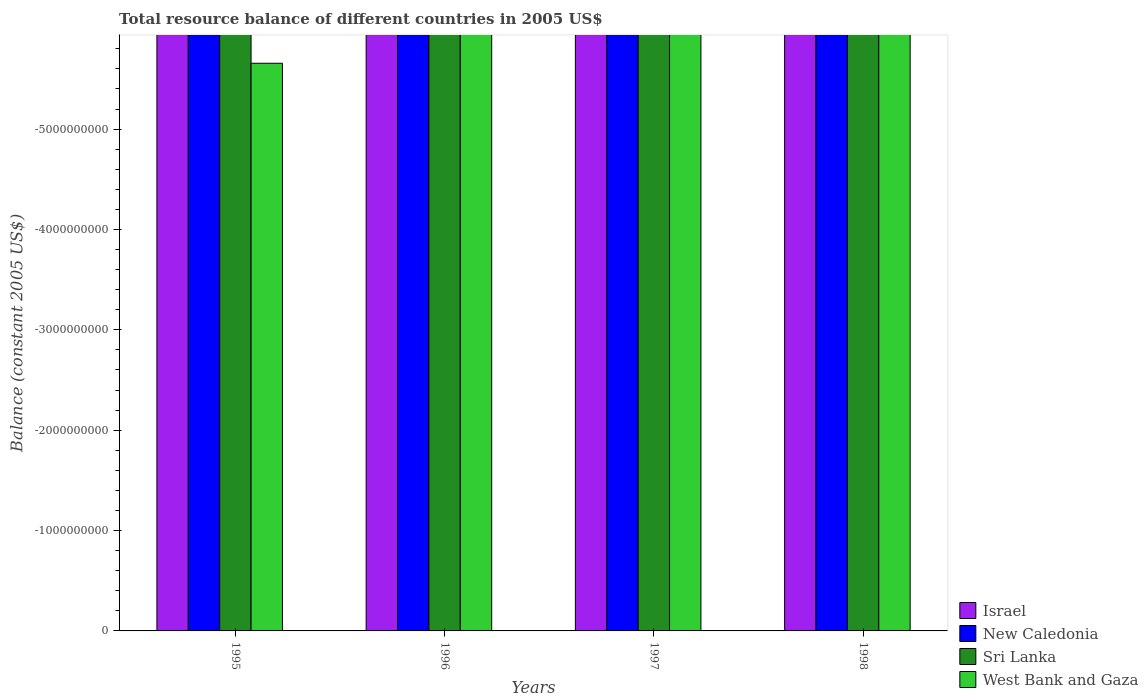Are the number of bars per tick equal to the number of legend labels?
Your response must be concise. No. Are the number of bars on each tick of the X-axis equal?
Give a very brief answer. Yes. How many bars are there on the 3rd tick from the left?
Provide a succinct answer. 0. In how many cases, is the number of bars for a given year not equal to the number of legend labels?
Keep it short and to the point. 4. In how many years, is the total resource balance in Sri Lanka greater than -5400000000 US$?
Keep it short and to the point. 0. Is it the case that in every year, the sum of the total resource balance in Israel and total resource balance in West Bank and Gaza is greater than the total resource balance in New Caledonia?
Keep it short and to the point. No. How many bars are there?
Ensure brevity in your answer.  0. How many years are there in the graph?
Provide a short and direct response. 4. What is the difference between two consecutive major ticks on the Y-axis?
Your response must be concise. 1.00e+09. Does the graph contain any zero values?
Offer a terse response. Yes. Does the graph contain grids?
Keep it short and to the point. No. What is the title of the graph?
Make the answer very short. Total resource balance of different countries in 2005 US$. What is the label or title of the Y-axis?
Offer a very short reply. Balance (constant 2005 US$). What is the Balance (constant 2005 US$) of New Caledonia in 1995?
Your answer should be very brief. 0. What is the Balance (constant 2005 US$) in West Bank and Gaza in 1995?
Your answer should be compact. 0. What is the Balance (constant 2005 US$) of Sri Lanka in 1996?
Your answer should be very brief. 0. What is the Balance (constant 2005 US$) in West Bank and Gaza in 1996?
Offer a very short reply. 0. What is the Balance (constant 2005 US$) of Israel in 1997?
Keep it short and to the point. 0. What is the Balance (constant 2005 US$) of Sri Lanka in 1997?
Make the answer very short. 0. What is the Balance (constant 2005 US$) in West Bank and Gaza in 1997?
Your answer should be very brief. 0. What is the Balance (constant 2005 US$) in Israel in 1998?
Your answer should be compact. 0. What is the Balance (constant 2005 US$) of West Bank and Gaza in 1998?
Offer a very short reply. 0. What is the total Balance (constant 2005 US$) in Israel in the graph?
Keep it short and to the point. 0. What is the total Balance (constant 2005 US$) of New Caledonia in the graph?
Provide a short and direct response. 0. What is the total Balance (constant 2005 US$) of Sri Lanka in the graph?
Offer a very short reply. 0. What is the total Balance (constant 2005 US$) of West Bank and Gaza in the graph?
Provide a short and direct response. 0. What is the average Balance (constant 2005 US$) of Sri Lanka per year?
Your response must be concise. 0. 